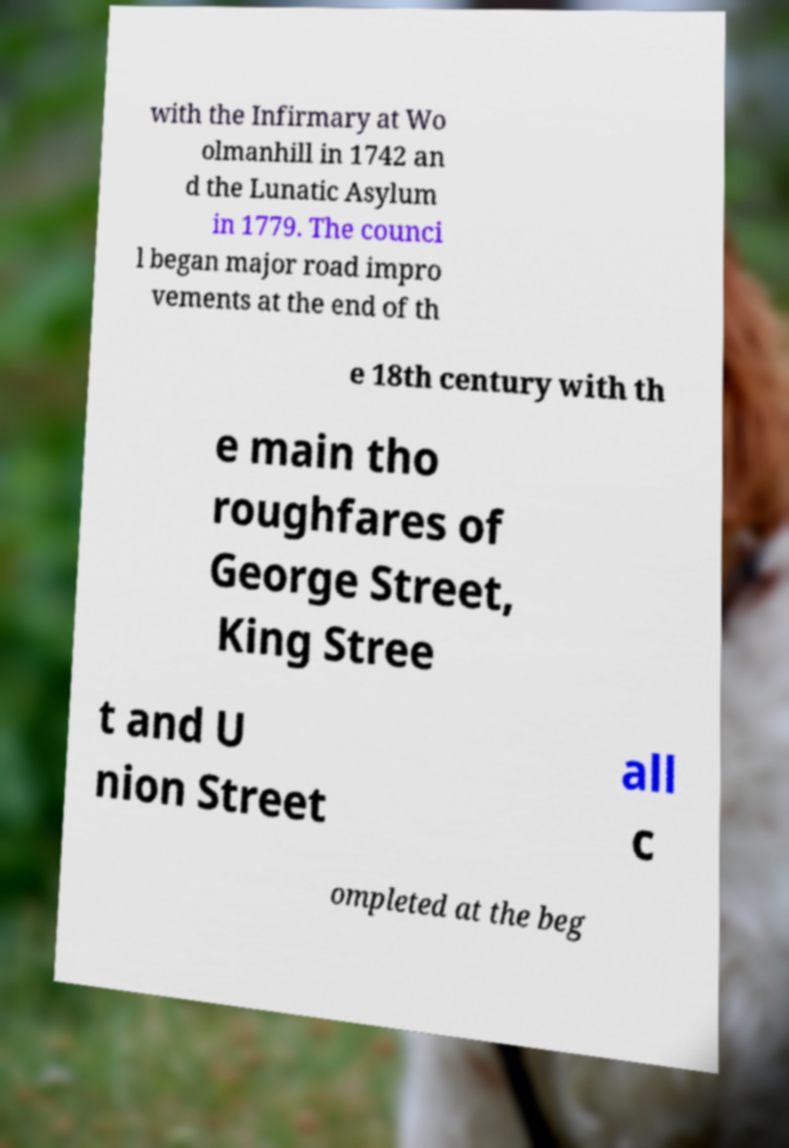Can you accurately transcribe the text from the provided image for me? with the Infirmary at Wo olmanhill in 1742 an d the Lunatic Asylum in 1779. The counci l began major road impro vements at the end of th e 18th century with th e main tho roughfares of George Street, King Stree t and U nion Street all c ompleted at the beg 